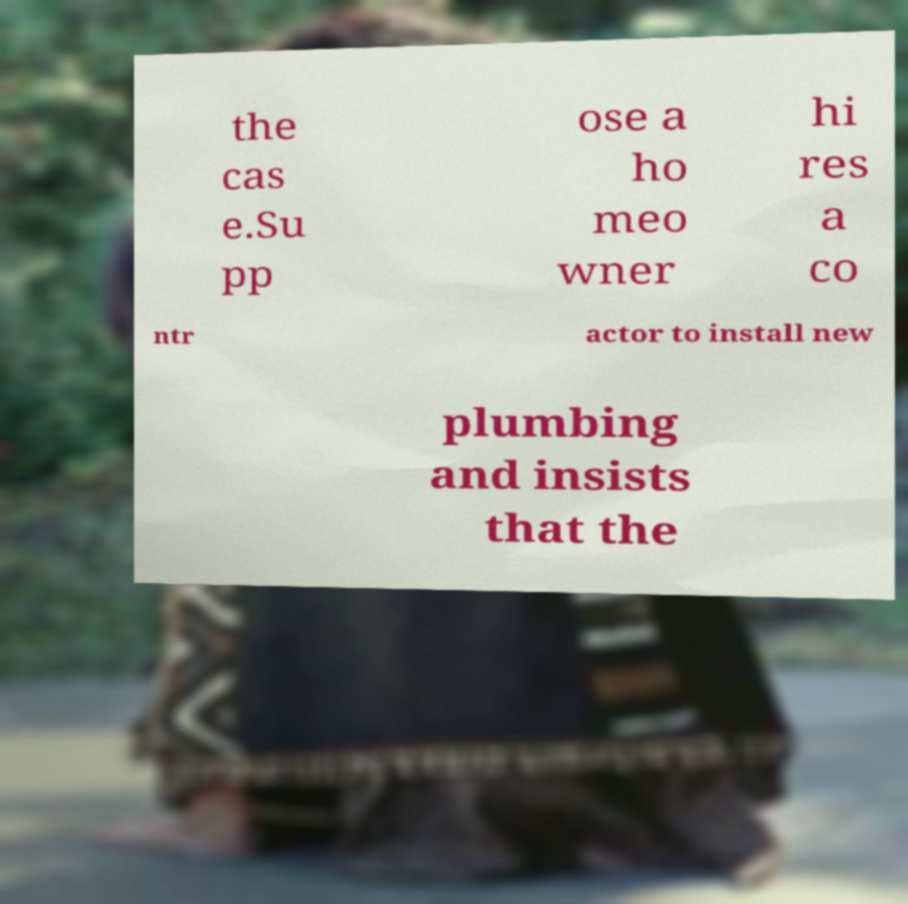What messages or text are displayed in this image? I need them in a readable, typed format. the cas e.Su pp ose a ho meo wner hi res a co ntr actor to install new plumbing and insists that the 